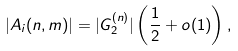Convert formula to latex. <formula><loc_0><loc_0><loc_500><loc_500>| A _ { i } ( n , m ) | = | G _ { 2 } ^ { ( n ) } | \left ( \frac { 1 } { 2 } + o ( 1 ) \right ) ,</formula> 